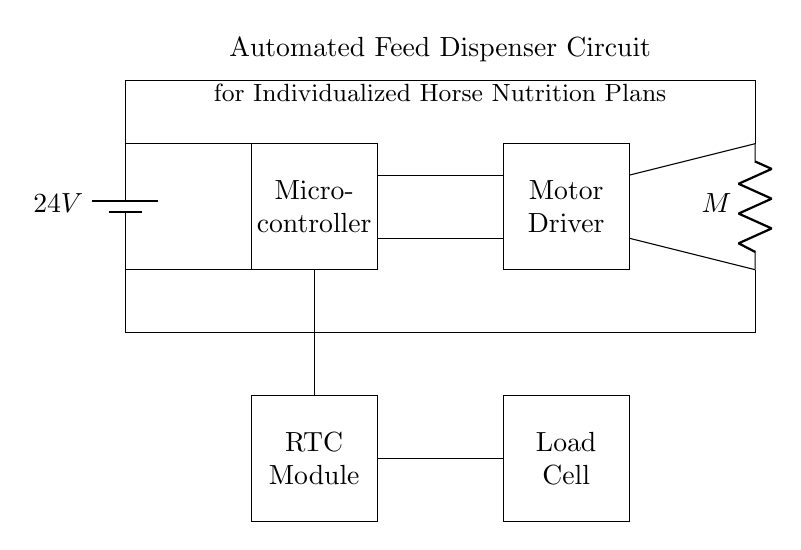What is the voltage supplied to the circuit? The circuit is powered by a battery labeled with a voltage of 24V, indicating the potential difference supplied to all components in the circuit.
Answer: 24V What component controls the distribution of power to the motor? The motor driver, depicted as a rectangle, is responsible for controlling the power and operation of the motor based on signals received from the microcontroller.
Answer: Motor Driver How many main components are connected to the microcontroller? The microcontroller connects to four main components: the motor driver, RTC module, load cell, and the power supply lines.
Answer: Four Which component is responsible for tracking feeding schedules? The RTC module, shown as a rectangle below the microcontroller, is used to keep track of real-time clock information for scheduling feed dispensing.
Answer: RTC Module What does the load cell measure in this circuit? The load cell measures the weight of the feed dispensed, providing feedback to the microcontroller to ensure the correct amount is delivered according to the horse's nutrition plan.
Answer: Weight How does the microcontroller communicate with the RTC module? The microcontroller communicates with the RTC module through a straight wire connection, which allows it to receive time data necessary for scheduling feeding.
Answer: Direct connection What is the role of the DC motor in this circuit? The DC motor drives the mechanism that dispenses the feed, functioning as an actuator that moves the feed based on commands from the motor driver and microcontroller.
Answer: Dispenses feed 